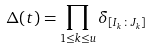Convert formula to latex. <formula><loc_0><loc_0><loc_500><loc_500>\Delta ( t ) = \prod _ { 1 \leq k \leq u } \delta _ { [ I _ { k } \colon J _ { k } ] }</formula> 